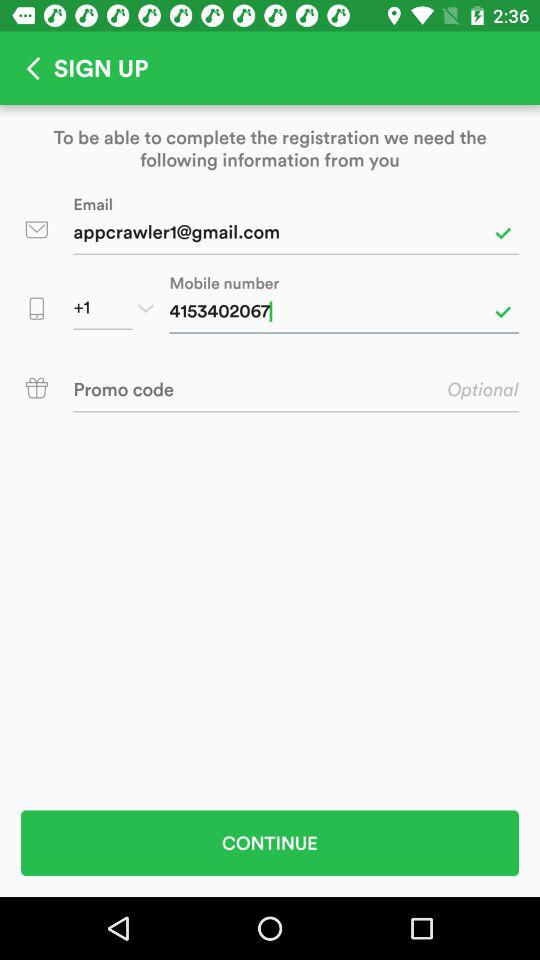How many check marks are there in this form?
Answer the question using a single word or phrase. 2 